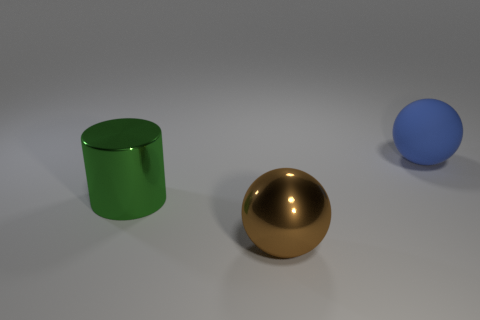For a scene like this, what could be potential uses or stories you could associate with it? This image could represent a simplified simulation environment for testing physics in a virtual space, where the differing materials of the objects might affect their interactions. Alternatively, it could be part of an educational tool for explaining concepts such as light, color, or geometry. In a more imaginative context, one might envision these objects as entities in a minimalist storytelling experience, where the golden ball is the 'protagonist' exploring a sparse but mysterious landscape. 